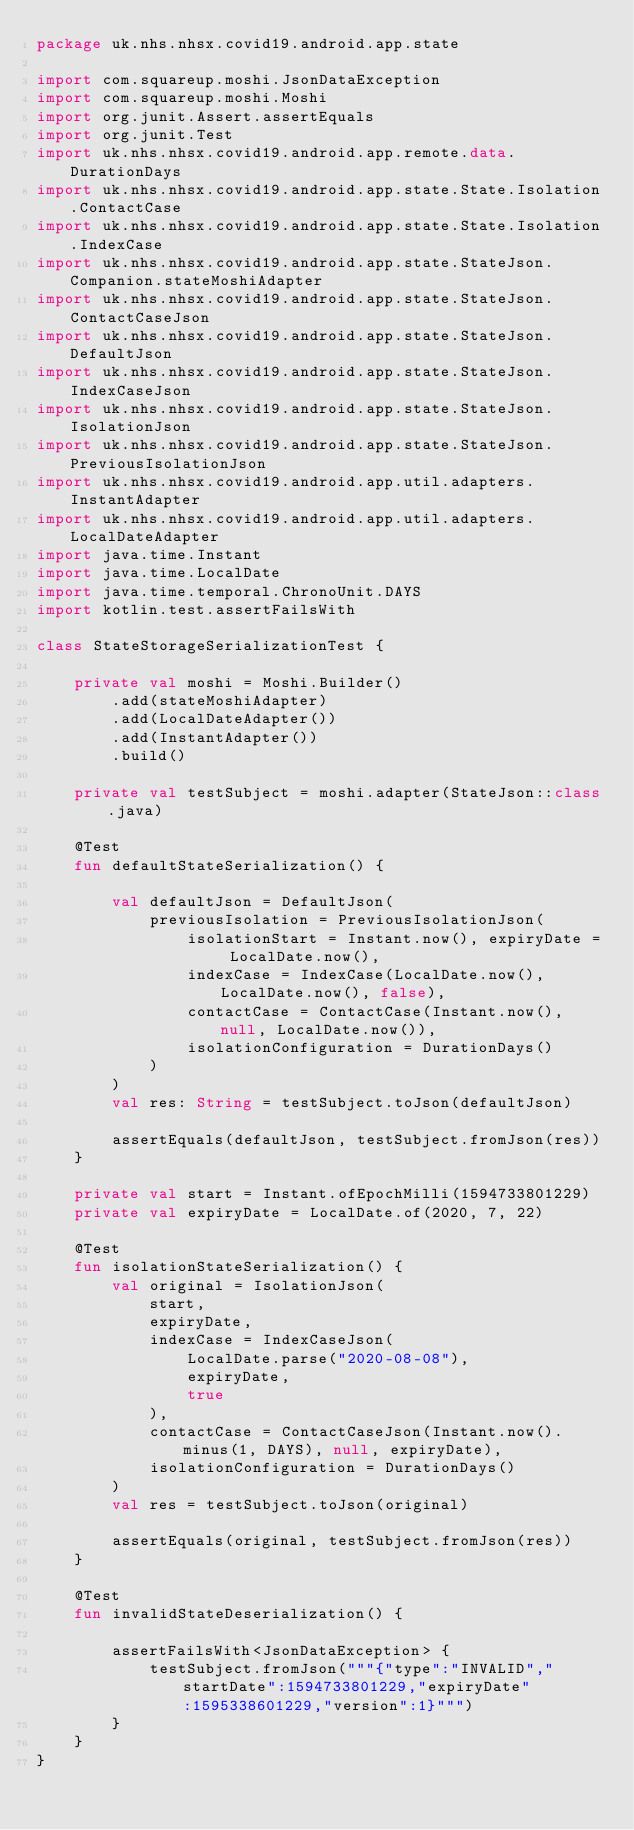Convert code to text. <code><loc_0><loc_0><loc_500><loc_500><_Kotlin_>package uk.nhs.nhsx.covid19.android.app.state

import com.squareup.moshi.JsonDataException
import com.squareup.moshi.Moshi
import org.junit.Assert.assertEquals
import org.junit.Test
import uk.nhs.nhsx.covid19.android.app.remote.data.DurationDays
import uk.nhs.nhsx.covid19.android.app.state.State.Isolation.ContactCase
import uk.nhs.nhsx.covid19.android.app.state.State.Isolation.IndexCase
import uk.nhs.nhsx.covid19.android.app.state.StateJson.Companion.stateMoshiAdapter
import uk.nhs.nhsx.covid19.android.app.state.StateJson.ContactCaseJson
import uk.nhs.nhsx.covid19.android.app.state.StateJson.DefaultJson
import uk.nhs.nhsx.covid19.android.app.state.StateJson.IndexCaseJson
import uk.nhs.nhsx.covid19.android.app.state.StateJson.IsolationJson
import uk.nhs.nhsx.covid19.android.app.state.StateJson.PreviousIsolationJson
import uk.nhs.nhsx.covid19.android.app.util.adapters.InstantAdapter
import uk.nhs.nhsx.covid19.android.app.util.adapters.LocalDateAdapter
import java.time.Instant
import java.time.LocalDate
import java.time.temporal.ChronoUnit.DAYS
import kotlin.test.assertFailsWith

class StateStorageSerializationTest {

    private val moshi = Moshi.Builder()
        .add(stateMoshiAdapter)
        .add(LocalDateAdapter())
        .add(InstantAdapter())
        .build()

    private val testSubject = moshi.adapter(StateJson::class.java)

    @Test
    fun defaultStateSerialization() {

        val defaultJson = DefaultJson(
            previousIsolation = PreviousIsolationJson(
                isolationStart = Instant.now(), expiryDate = LocalDate.now(),
                indexCase = IndexCase(LocalDate.now(), LocalDate.now(), false),
                contactCase = ContactCase(Instant.now(), null, LocalDate.now()),
                isolationConfiguration = DurationDays()
            )
        )
        val res: String = testSubject.toJson(defaultJson)

        assertEquals(defaultJson, testSubject.fromJson(res))
    }

    private val start = Instant.ofEpochMilli(1594733801229)
    private val expiryDate = LocalDate.of(2020, 7, 22)

    @Test
    fun isolationStateSerialization() {
        val original = IsolationJson(
            start,
            expiryDate,
            indexCase = IndexCaseJson(
                LocalDate.parse("2020-08-08"),
                expiryDate,
                true
            ),
            contactCase = ContactCaseJson(Instant.now().minus(1, DAYS), null, expiryDate),
            isolationConfiguration = DurationDays()
        )
        val res = testSubject.toJson(original)

        assertEquals(original, testSubject.fromJson(res))
    }

    @Test
    fun invalidStateDeserialization() {

        assertFailsWith<JsonDataException> {
            testSubject.fromJson("""{"type":"INVALID","startDate":1594733801229,"expiryDate":1595338601229,"version":1}""")
        }
    }
}
</code> 